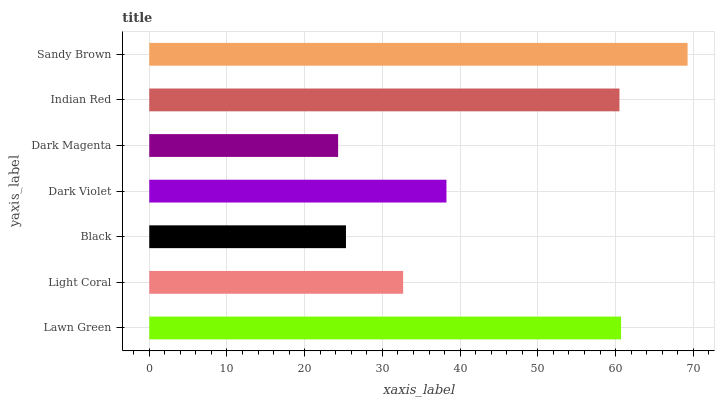Is Dark Magenta the minimum?
Answer yes or no. Yes. Is Sandy Brown the maximum?
Answer yes or no. Yes. Is Light Coral the minimum?
Answer yes or no. No. Is Light Coral the maximum?
Answer yes or no. No. Is Lawn Green greater than Light Coral?
Answer yes or no. Yes. Is Light Coral less than Lawn Green?
Answer yes or no. Yes. Is Light Coral greater than Lawn Green?
Answer yes or no. No. Is Lawn Green less than Light Coral?
Answer yes or no. No. Is Dark Violet the high median?
Answer yes or no. Yes. Is Dark Violet the low median?
Answer yes or no. Yes. Is Black the high median?
Answer yes or no. No. Is Sandy Brown the low median?
Answer yes or no. No. 